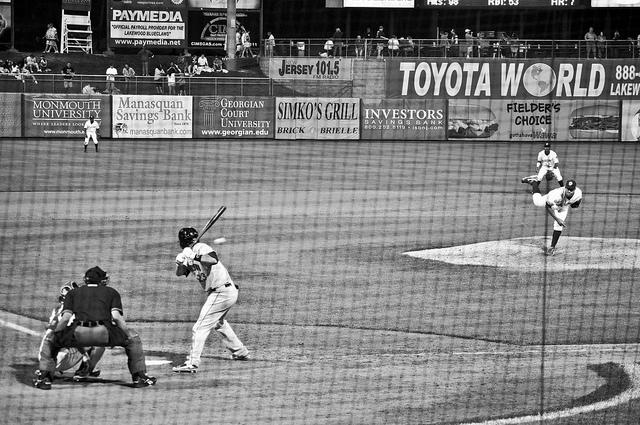Does this stadium have corporate sponsors?
Keep it brief. Yes. What car company is being advertised?
Answer briefly. Toyota. Is the umpire standing straight up?
Quick response, please. No. What car brand is being advertised?
Concise answer only. Toyota. What color is the grass?
Give a very brief answer. Green. 